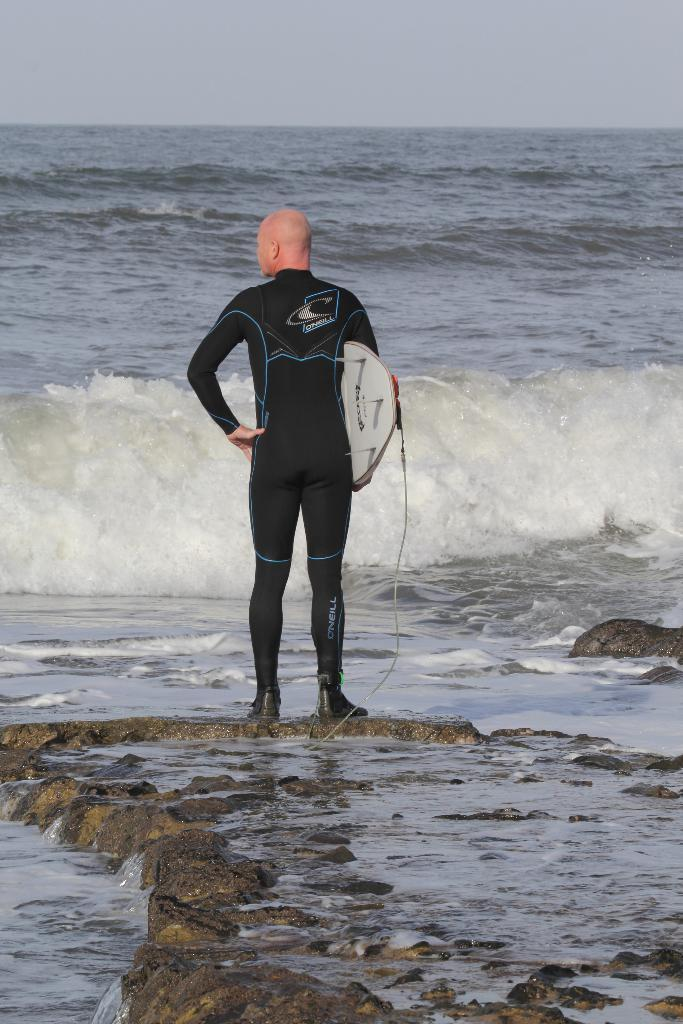What is the main subject of the image? There is a person standing in the center of the image. What is the person holding in the image? The person is holding a board. What can be seen in the background of the image? There is water visible in the background of the image. What is present at the bottom of the image? There are rocks at the bottom of the image. What is visible at the top of the image? The sky is visible at the top of the image. What type of tin can be seen next to the person in the image? There is no tin present in the image. Is the person's sister standing next to them in the image? The provided facts do not mention the presence of a sister, so it cannot be determined from the image. 